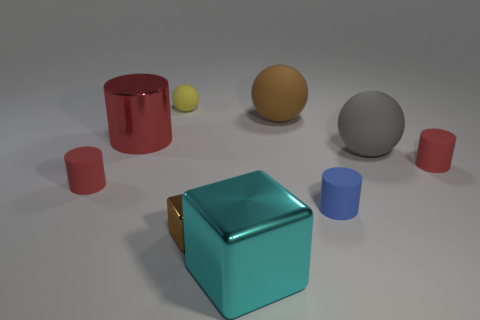Can you describe the arrangement of objects on the table? Certainly! The image features a collection of objects arranged on a surface, seemingly at random. In the foreground, there's a prominent teal cube with a reflective surface, possibly made of metal. Scattered around it are several cylinders of varying sizes and colors, including red and blue, along with a few spheres in yellow and gray tones. The arrangement gives off a sense of spatial diversity with objects of different shapes and colors. 